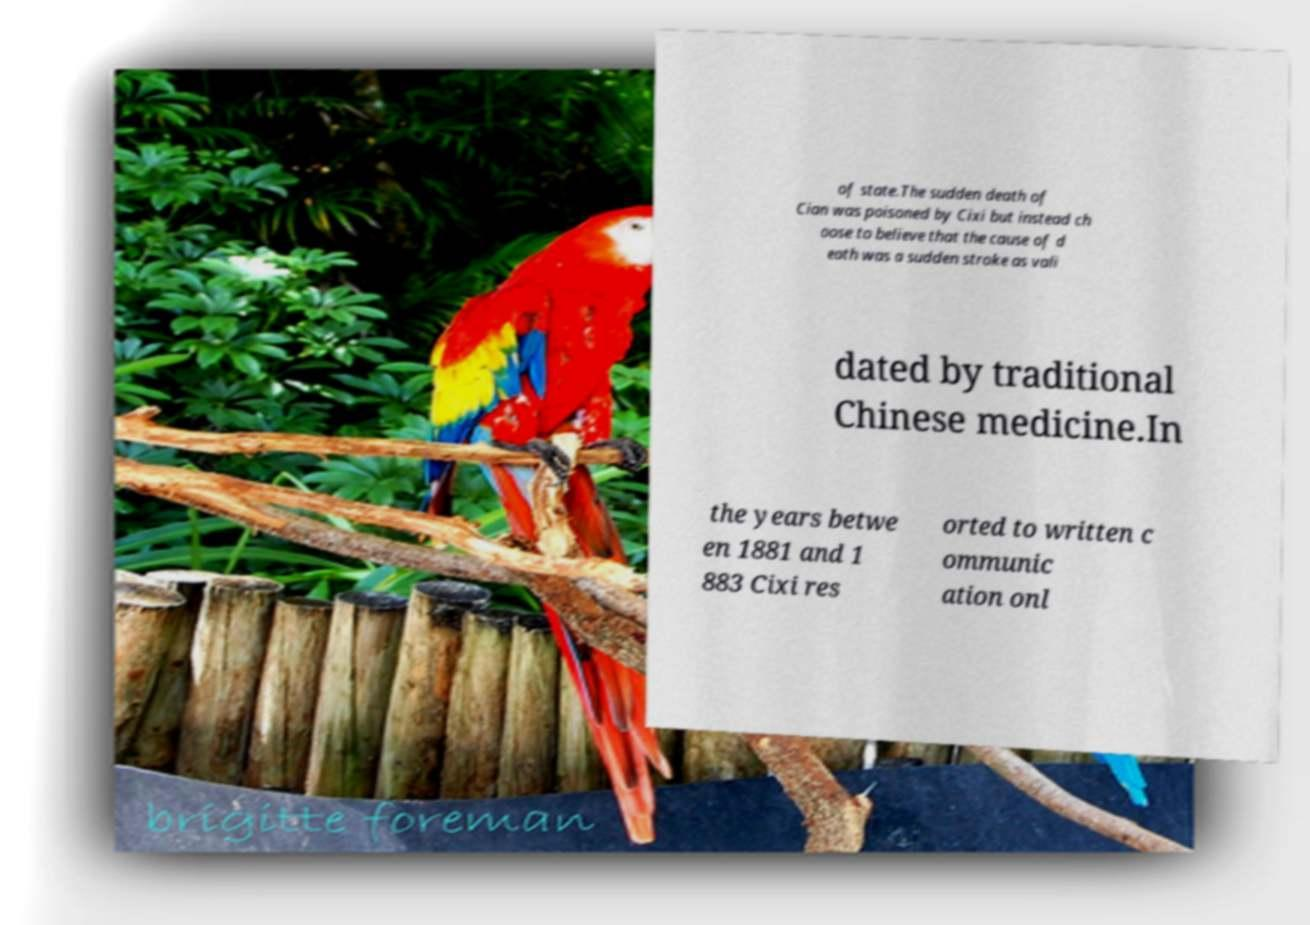For documentation purposes, I need the text within this image transcribed. Could you provide that? of state.The sudden death of Cian was poisoned by Cixi but instead ch oose to believe that the cause of d eath was a sudden stroke as vali dated by traditional Chinese medicine.In the years betwe en 1881 and 1 883 Cixi res orted to written c ommunic ation onl 